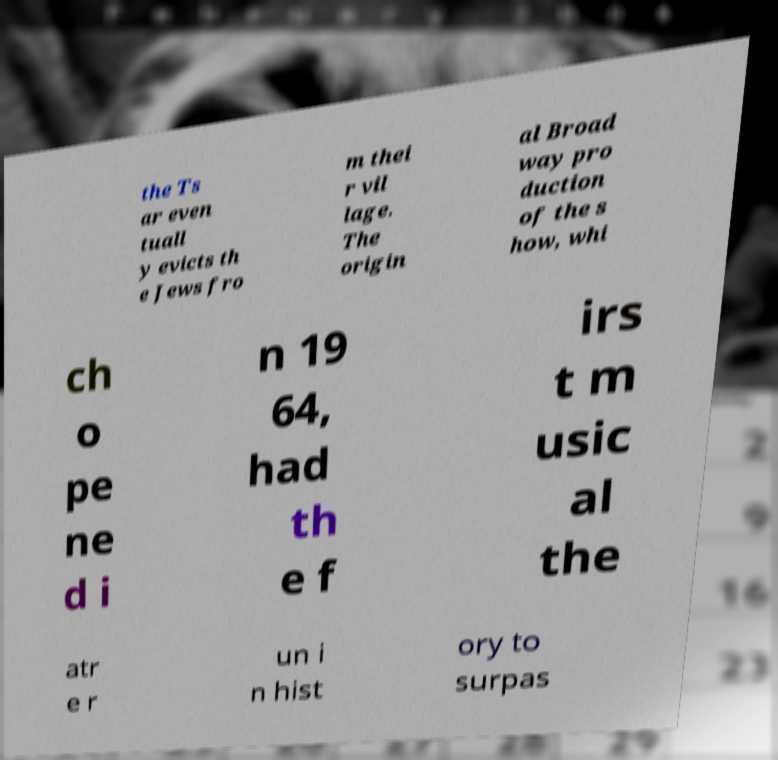Please read and relay the text visible in this image. What does it say? the Ts ar even tuall y evicts th e Jews fro m thei r vil lage. The origin al Broad way pro duction of the s how, whi ch o pe ne d i n 19 64, had th e f irs t m usic al the atr e r un i n hist ory to surpas 